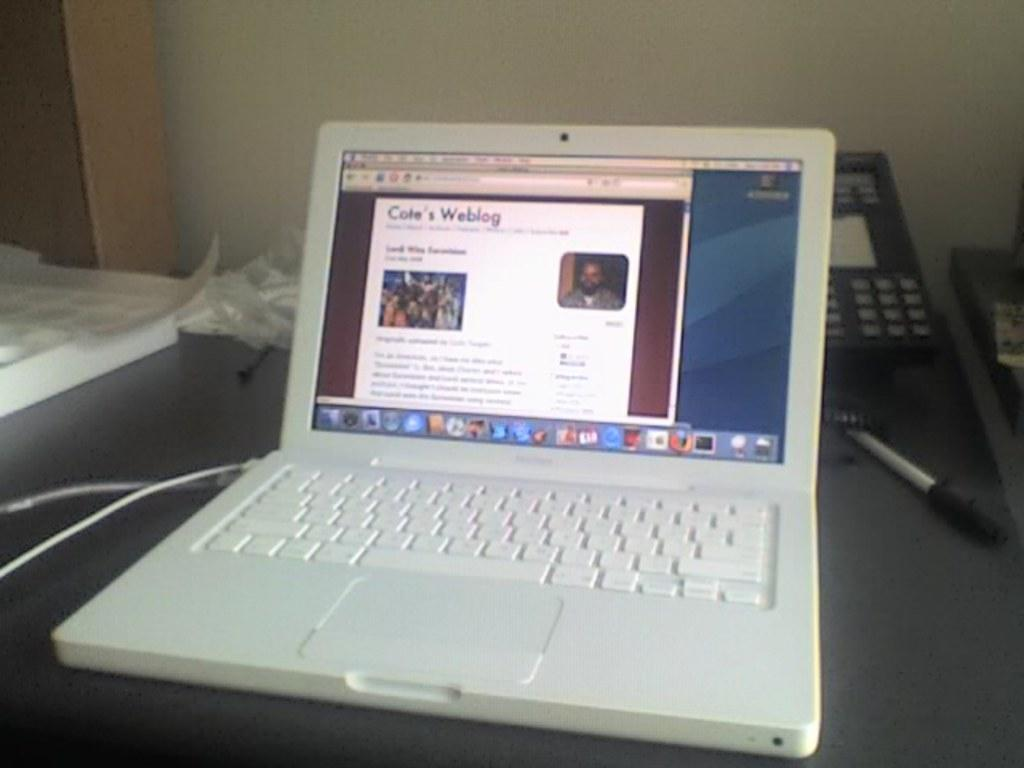Provide a one-sentence caption for the provided image. White laptop showing Cole's Wedding on the screen. 